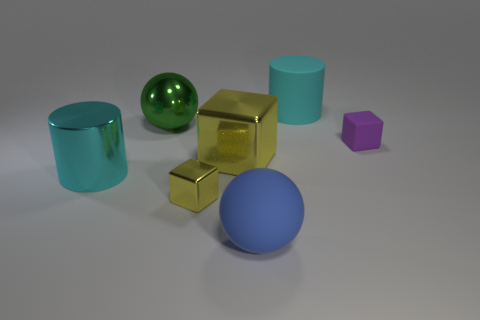Are there fewer small purple objects that are in front of the cyan metal cylinder than green metallic things?
Ensure brevity in your answer.  Yes. Do the blue sphere and the purple block have the same material?
Provide a succinct answer. Yes. What is the size of the green thing that is the same shape as the big blue object?
Keep it short and to the point. Large. How many things are either metal things behind the purple matte object or big rubber things that are behind the big blue thing?
Ensure brevity in your answer.  2. Are there fewer big blocks than blocks?
Offer a terse response. Yes. Does the purple rubber block have the same size as the shiny block in front of the big yellow object?
Make the answer very short. Yes. What number of shiny things are either small yellow spheres or spheres?
Give a very brief answer. 1. Is the number of things greater than the number of blue spheres?
Your response must be concise. Yes. What size is the thing that is the same color as the large metallic cube?
Your answer should be very brief. Small. What is the shape of the cyan object to the right of the big cyan object that is left of the big blue matte object?
Provide a succinct answer. Cylinder. 